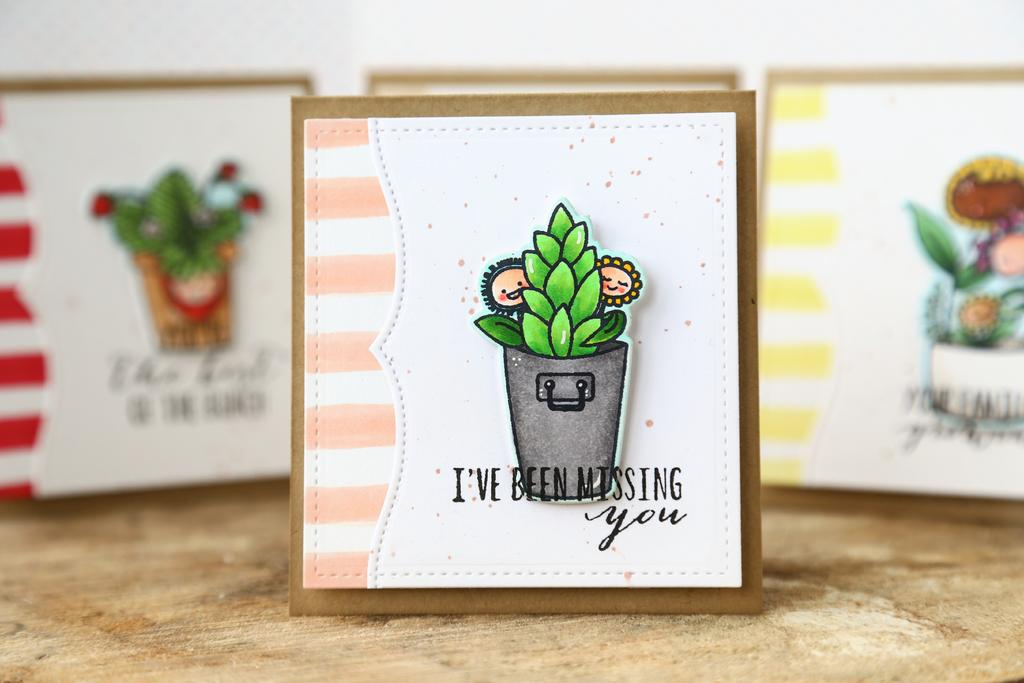What materials are visible in the image? There are cardboards in the image. What is attached to the cardboards? Papers are pasted on the cardboards. What type of snail can be seen crawling on the cardboards in the image? There are no snails present in the image; it only features cardboards with papers pasted on them. 